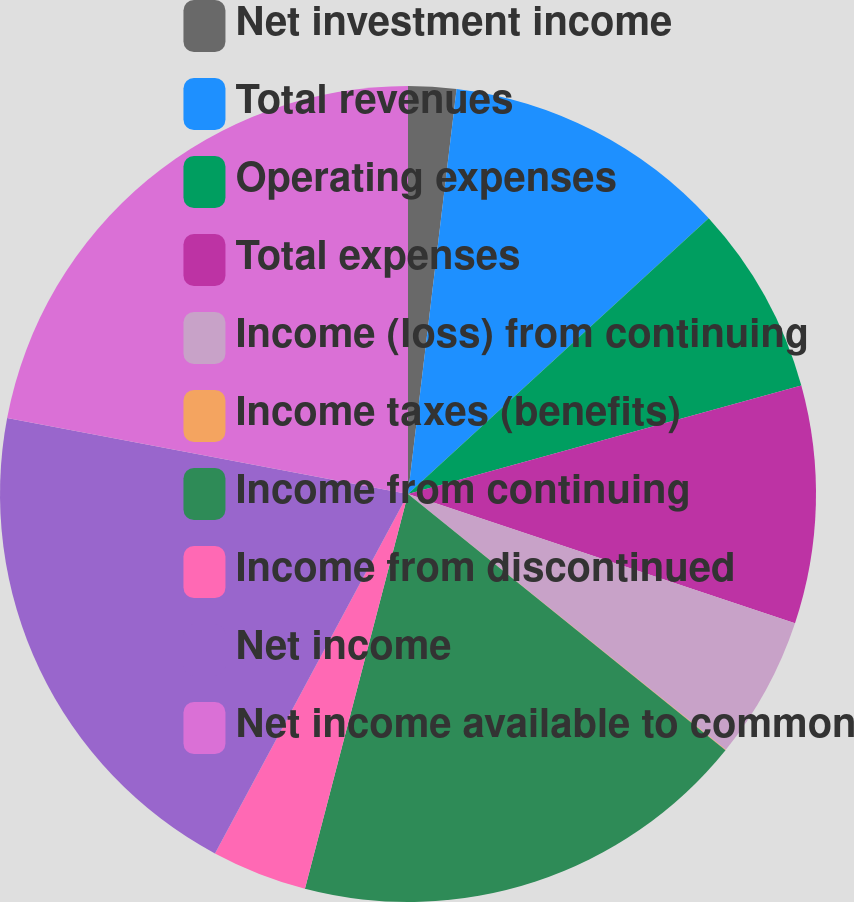Convert chart to OTSL. <chart><loc_0><loc_0><loc_500><loc_500><pie_chart><fcel>Net investment income<fcel>Total revenues<fcel>Operating expenses<fcel>Total expenses<fcel>Income (loss) from continuing<fcel>Income taxes (benefits)<fcel>Income from continuing<fcel>Income from discontinued<fcel>Net income<fcel>Net income available to common<nl><fcel>1.9%<fcel>11.29%<fcel>7.53%<fcel>9.41%<fcel>5.66%<fcel>0.02%<fcel>18.26%<fcel>3.78%<fcel>20.14%<fcel>22.02%<nl></chart> 